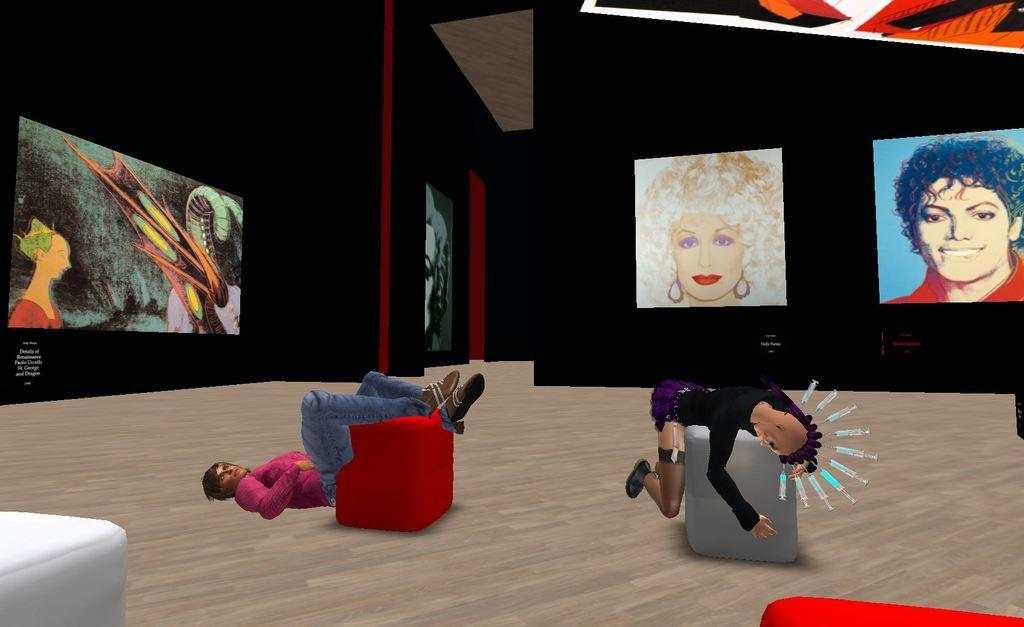What type of image is being described? The image is an animation. What type of furniture is present in the image? There are couches in the image. Are there any people in the image? Yes, there are people in the image. What can be seen in the background of the image? There are screens in the background of the image. Is there any smoke coming from the car in the image? There is no car present in the image, so there is no smoke coming from a car. 